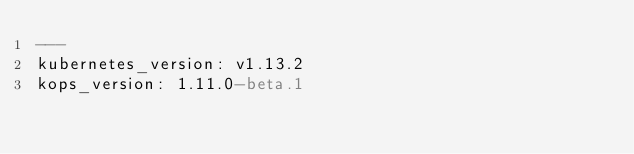Convert code to text. <code><loc_0><loc_0><loc_500><loc_500><_YAML_>---
kubernetes_version: v1.13.2
kops_version: 1.11.0-beta.1
</code> 